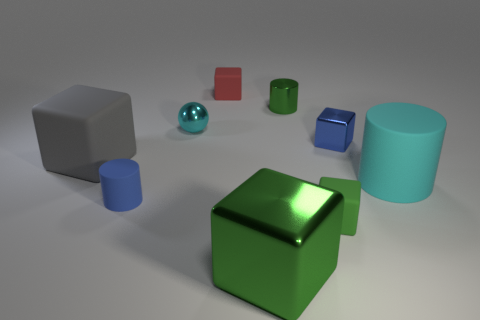There is a blue thing to the right of the large green metal object; what is it made of?
Make the answer very short. Metal. Is the shape of the small blue thing left of the tiny cyan metallic sphere the same as the tiny green thing that is in front of the large matte cylinder?
Offer a very short reply. No. Are there an equal number of cylinders that are in front of the small cyan thing and small brown cylinders?
Offer a terse response. No. How many tiny gray spheres have the same material as the big cyan cylinder?
Provide a succinct answer. 0. What color is the other cylinder that is made of the same material as the cyan cylinder?
Your response must be concise. Blue. There is a cyan sphere; does it have the same size as the green metal object that is behind the blue cylinder?
Your response must be concise. Yes. What is the shape of the big green thing?
Your answer should be compact. Cube. How many big rubber things are the same color as the metal cylinder?
Keep it short and to the point. 0. What color is the other metal thing that is the same shape as the blue metallic object?
Provide a short and direct response. Green. There is a cube that is behind the tiny ball; how many large matte blocks are behind it?
Offer a terse response. 0. 